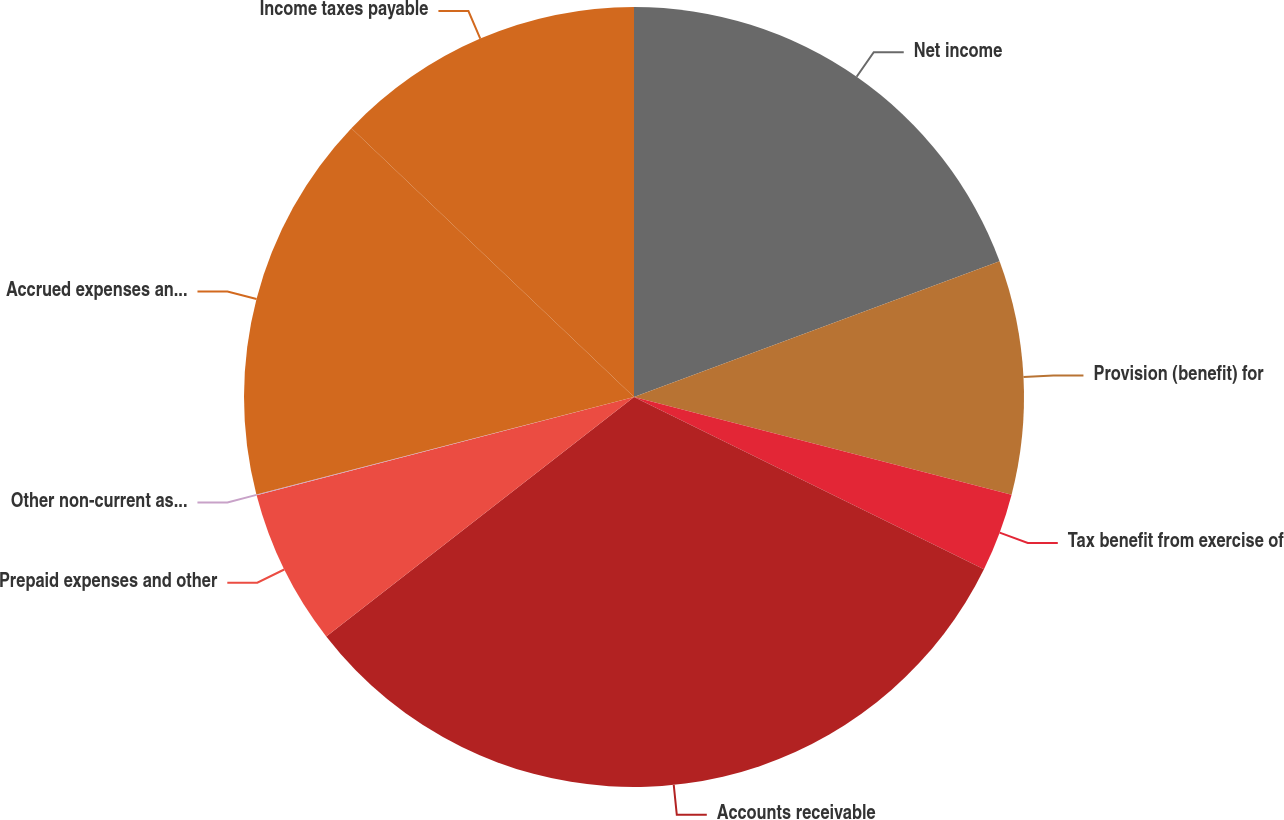Convert chart to OTSL. <chart><loc_0><loc_0><loc_500><loc_500><pie_chart><fcel>Net income<fcel>Provision (benefit) for<fcel>Tax benefit from exercise of<fcel>Accounts receivable<fcel>Prepaid expenses and other<fcel>Other non-current assets<fcel>Accrued expenses and other<fcel>Income taxes payable<nl><fcel>19.34%<fcel>9.69%<fcel>3.25%<fcel>32.2%<fcel>6.47%<fcel>0.04%<fcel>16.12%<fcel>12.9%<nl></chart> 